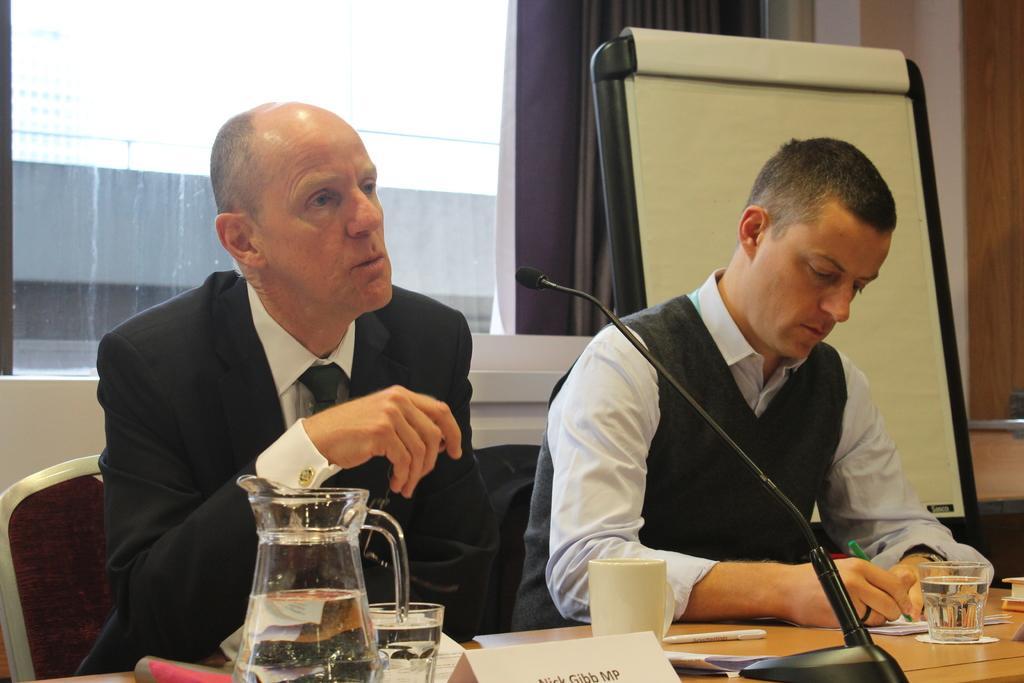Could you give a brief overview of what you see in this image? The two persons are sitting on a chair. There is a table. There is a glass,jar,book,microphone on a table. We can see in a background window,curtain and board. 